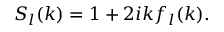Convert formula to latex. <formula><loc_0><loc_0><loc_500><loc_500>{ } S _ { l } ( k ) = 1 + 2 i k f _ { l } ( k ) .</formula> 